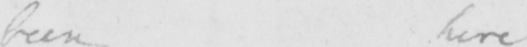What is written in this line of handwriting? been here 